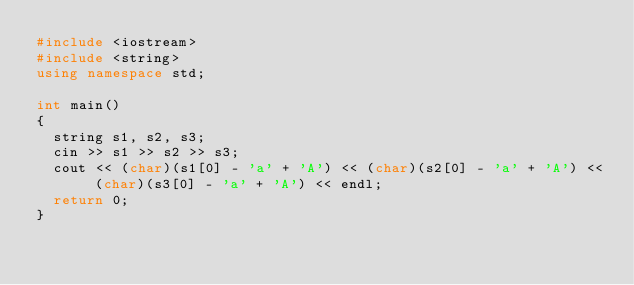Convert code to text. <code><loc_0><loc_0><loc_500><loc_500><_C++_>#include <iostream>
#include <string>
using namespace std;

int main()
{
	string s1, s2, s3;
	cin >> s1 >> s2 >> s3;
	cout << (char)(s1[0] - 'a' + 'A') << (char)(s2[0] - 'a' + 'A') << (char)(s3[0] - 'a' + 'A') << endl;
	return 0;
}</code> 